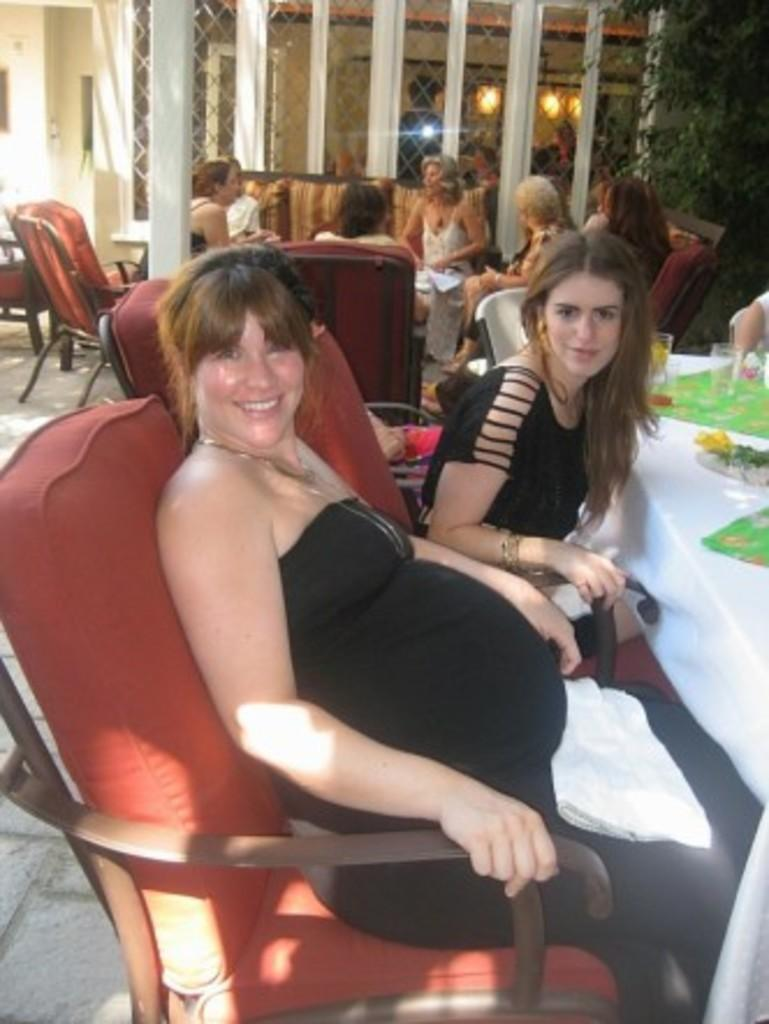What type of structure can be seen in the image? There is a wall in the image. What natural element is present in the image? There is a tree in the image. What are the people in the image doing? The people are sitting on chairs in the image. What piece of furniture is present in the image? There is a table in the image. What is covering the table in the image? There is a cloth present on the table. What object is on the table in the image? There is a glass on the table in the image. What type of farm animals can be seen grazing near the tree in the image? There are no farm animals present in the image; it only features a tree, a wall, people sitting on chairs, a table, a cloth, and a glass. What impulse caused the people to suddenly stand up and dance in the image? There is no indication of any impulse causing the people to stand up and dance in the image; they are simply sitting on chairs. 